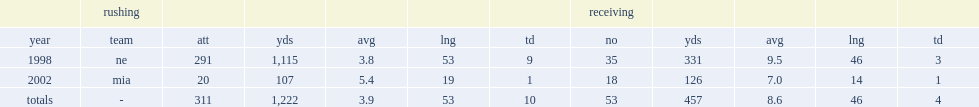How many yards did robert edwards rush in the 1998 season? 1115.0. 